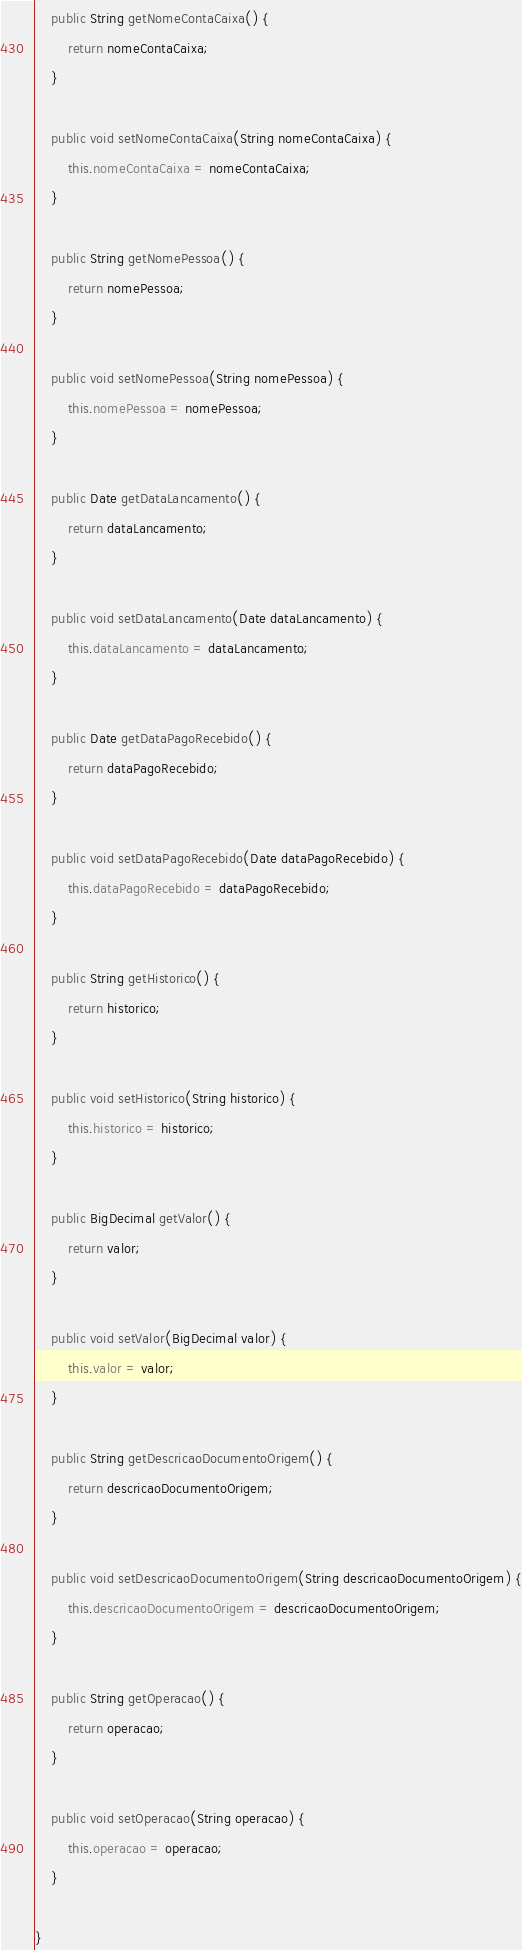<code> <loc_0><loc_0><loc_500><loc_500><_Java_>
    public String getNomeContaCaixa() {
        return nomeContaCaixa;
    }

    public void setNomeContaCaixa(String nomeContaCaixa) {
        this.nomeContaCaixa = nomeContaCaixa;
    }

    public String getNomePessoa() {
        return nomePessoa;
    }

    public void setNomePessoa(String nomePessoa) {
        this.nomePessoa = nomePessoa;
    }

    public Date getDataLancamento() {
        return dataLancamento;
    }

    public void setDataLancamento(Date dataLancamento) {
        this.dataLancamento = dataLancamento;
    }

    public Date getDataPagoRecebido() {
        return dataPagoRecebido;
    }

    public void setDataPagoRecebido(Date dataPagoRecebido) {
        this.dataPagoRecebido = dataPagoRecebido;
    }

    public String getHistorico() {
        return historico;
    }

    public void setHistorico(String historico) {
        this.historico = historico;
    }

    public BigDecimal getValor() {
        return valor;
    }

    public void setValor(BigDecimal valor) {
        this.valor = valor;
    }

    public String getDescricaoDocumentoOrigem() {
        return descricaoDocumentoOrigem;
    }

    public void setDescricaoDocumentoOrigem(String descricaoDocumentoOrigem) {
        this.descricaoDocumentoOrigem = descricaoDocumentoOrigem;
    }

    public String getOperacao() {
        return operacao;
    }

    public void setOperacao(String operacao) {
        this.operacao = operacao;
    }

}
</code> 